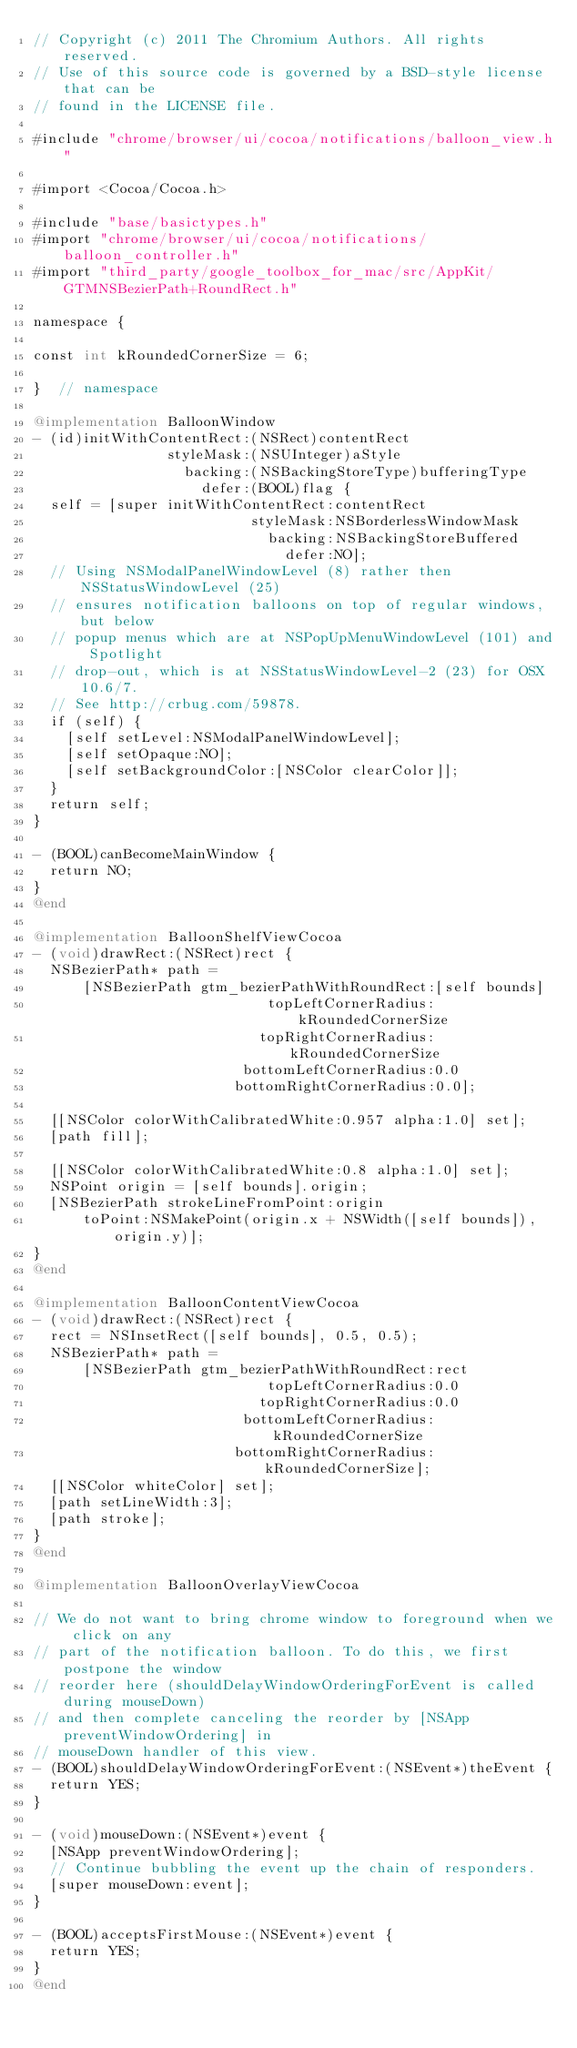Convert code to text. <code><loc_0><loc_0><loc_500><loc_500><_ObjectiveC_>// Copyright (c) 2011 The Chromium Authors. All rights reserved.
// Use of this source code is governed by a BSD-style license that can be
// found in the LICENSE file.

#include "chrome/browser/ui/cocoa/notifications/balloon_view.h"

#import <Cocoa/Cocoa.h>

#include "base/basictypes.h"
#import "chrome/browser/ui/cocoa/notifications/balloon_controller.h"
#import "third_party/google_toolbox_for_mac/src/AppKit/GTMNSBezierPath+RoundRect.h"

namespace {

const int kRoundedCornerSize = 6;

}  // namespace

@implementation BalloonWindow
- (id)initWithContentRect:(NSRect)contentRect
                styleMask:(NSUInteger)aStyle
                  backing:(NSBackingStoreType)bufferingType
                    defer:(BOOL)flag {
  self = [super initWithContentRect:contentRect
                          styleMask:NSBorderlessWindowMask
                            backing:NSBackingStoreBuffered
                              defer:NO];
  // Using NSModalPanelWindowLevel (8) rather then NSStatusWindowLevel (25)
  // ensures notification balloons on top of regular windows, but below
  // popup menus which are at NSPopUpMenuWindowLevel (101) and Spotlight
  // drop-out, which is at NSStatusWindowLevel-2 (23) for OSX 10.6/7.
  // See http://crbug.com/59878.
  if (self) {
    [self setLevel:NSModalPanelWindowLevel];
    [self setOpaque:NO];
    [self setBackgroundColor:[NSColor clearColor]];
  }
  return self;
}

- (BOOL)canBecomeMainWindow {
  return NO;
}
@end

@implementation BalloonShelfViewCocoa
- (void)drawRect:(NSRect)rect {
  NSBezierPath* path =
      [NSBezierPath gtm_bezierPathWithRoundRect:[self bounds]
                            topLeftCornerRadius:kRoundedCornerSize
                           topRightCornerRadius:kRoundedCornerSize
                         bottomLeftCornerRadius:0.0
                        bottomRightCornerRadius:0.0];

  [[NSColor colorWithCalibratedWhite:0.957 alpha:1.0] set];
  [path fill];

  [[NSColor colorWithCalibratedWhite:0.8 alpha:1.0] set];
  NSPoint origin = [self bounds].origin;
  [NSBezierPath strokeLineFromPoint:origin
      toPoint:NSMakePoint(origin.x + NSWidth([self bounds]), origin.y)];
}
@end

@implementation BalloonContentViewCocoa
- (void)drawRect:(NSRect)rect {
  rect = NSInsetRect([self bounds], 0.5, 0.5);
  NSBezierPath* path =
      [NSBezierPath gtm_bezierPathWithRoundRect:rect
                            topLeftCornerRadius:0.0
                           topRightCornerRadius:0.0
                         bottomLeftCornerRadius:kRoundedCornerSize
                        bottomRightCornerRadius:kRoundedCornerSize];
  [[NSColor whiteColor] set];
  [path setLineWidth:3];
  [path stroke];
}
@end

@implementation BalloonOverlayViewCocoa

// We do not want to bring chrome window to foreground when we click on any
// part of the notification balloon. To do this, we first postpone the window
// reorder here (shouldDelayWindowOrderingForEvent is called during mouseDown)
// and then complete canceling the reorder by [NSApp preventWindowOrdering] in
// mouseDown handler of this view.
- (BOOL)shouldDelayWindowOrderingForEvent:(NSEvent*)theEvent {
  return YES;
}

- (void)mouseDown:(NSEvent*)event {
  [NSApp preventWindowOrdering];
  // Continue bubbling the event up the chain of responders.
  [super mouseDown:event];
}

- (BOOL)acceptsFirstMouse:(NSEvent*)event {
  return YES;
}
@end
</code> 